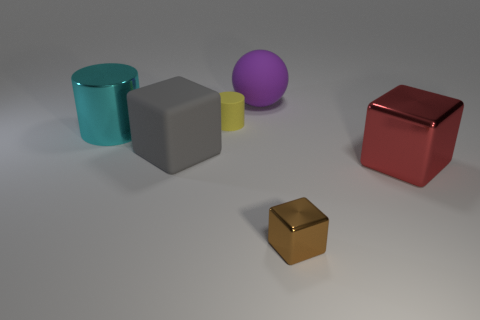Add 2 big metallic things. How many objects exist? 8 Subtract all cylinders. How many objects are left? 4 Add 1 big rubber cubes. How many big rubber cubes exist? 2 Subtract 0 blue cubes. How many objects are left? 6 Subtract all green rubber balls. Subtract all small cylinders. How many objects are left? 5 Add 2 tiny brown metal cubes. How many tiny brown metal cubes are left? 3 